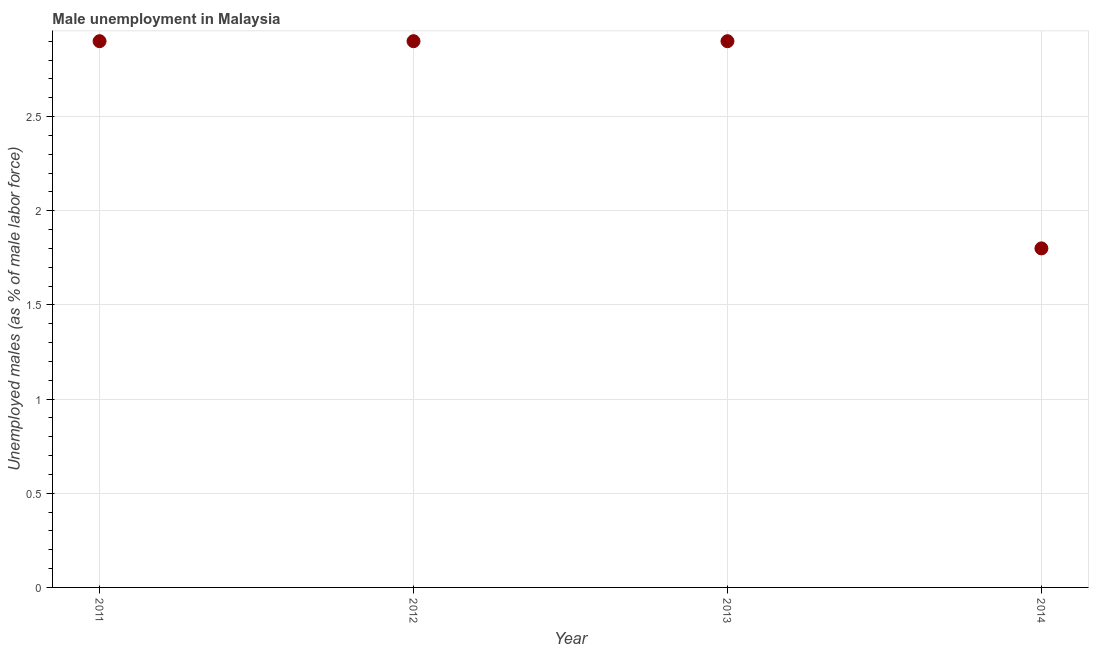What is the unemployed males population in 2014?
Your answer should be very brief. 1.8. Across all years, what is the maximum unemployed males population?
Offer a terse response. 2.9. Across all years, what is the minimum unemployed males population?
Give a very brief answer. 1.8. What is the sum of the unemployed males population?
Your answer should be very brief. 10.5. What is the difference between the unemployed males population in 2012 and 2014?
Offer a very short reply. 1.1. What is the average unemployed males population per year?
Offer a very short reply. 2.63. What is the median unemployed males population?
Ensure brevity in your answer.  2.9. In how many years, is the unemployed males population greater than 2.8 %?
Your answer should be compact. 3. Do a majority of the years between 2014 and 2013 (inclusive) have unemployed males population greater than 1.9 %?
Make the answer very short. No. What is the ratio of the unemployed males population in 2011 to that in 2014?
Provide a short and direct response. 1.61. Is the unemployed males population in 2012 less than that in 2014?
Your response must be concise. No. Is the sum of the unemployed males population in 2011 and 2014 greater than the maximum unemployed males population across all years?
Your answer should be very brief. Yes. What is the difference between the highest and the lowest unemployed males population?
Your answer should be very brief. 1.1. In how many years, is the unemployed males population greater than the average unemployed males population taken over all years?
Your answer should be very brief. 3. Does the unemployed males population monotonically increase over the years?
Provide a succinct answer. No. What is the difference between two consecutive major ticks on the Y-axis?
Ensure brevity in your answer.  0.5. Does the graph contain any zero values?
Keep it short and to the point. No. Does the graph contain grids?
Ensure brevity in your answer.  Yes. What is the title of the graph?
Your answer should be very brief. Male unemployment in Malaysia. What is the label or title of the Y-axis?
Your answer should be compact. Unemployed males (as % of male labor force). What is the Unemployed males (as % of male labor force) in 2011?
Give a very brief answer. 2.9. What is the Unemployed males (as % of male labor force) in 2012?
Give a very brief answer. 2.9. What is the Unemployed males (as % of male labor force) in 2013?
Offer a very short reply. 2.9. What is the Unemployed males (as % of male labor force) in 2014?
Offer a terse response. 1.8. What is the difference between the Unemployed males (as % of male labor force) in 2011 and 2012?
Offer a terse response. 0. What is the difference between the Unemployed males (as % of male labor force) in 2012 and 2014?
Your answer should be very brief. 1.1. What is the difference between the Unemployed males (as % of male labor force) in 2013 and 2014?
Your answer should be very brief. 1.1. What is the ratio of the Unemployed males (as % of male labor force) in 2011 to that in 2012?
Ensure brevity in your answer.  1. What is the ratio of the Unemployed males (as % of male labor force) in 2011 to that in 2014?
Offer a very short reply. 1.61. What is the ratio of the Unemployed males (as % of male labor force) in 2012 to that in 2014?
Your answer should be very brief. 1.61. What is the ratio of the Unemployed males (as % of male labor force) in 2013 to that in 2014?
Offer a terse response. 1.61. 